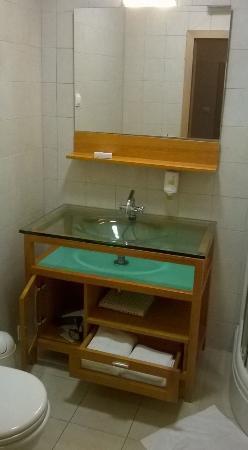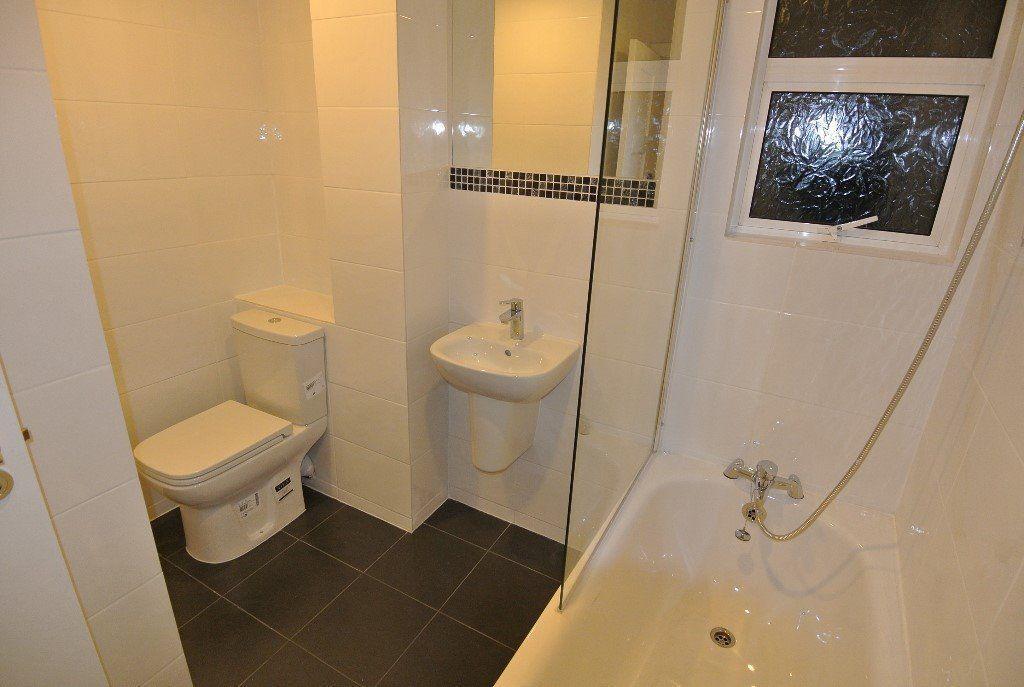The first image is the image on the left, the second image is the image on the right. Analyze the images presented: Is the assertion "There is a refrigerator next to a counter containing a wash basin." valid? Answer yes or no. No. The first image is the image on the left, the second image is the image on the right. Analyze the images presented: Is the assertion "A mirror sits over the sink in the image on the right." valid? Answer yes or no. Yes. 